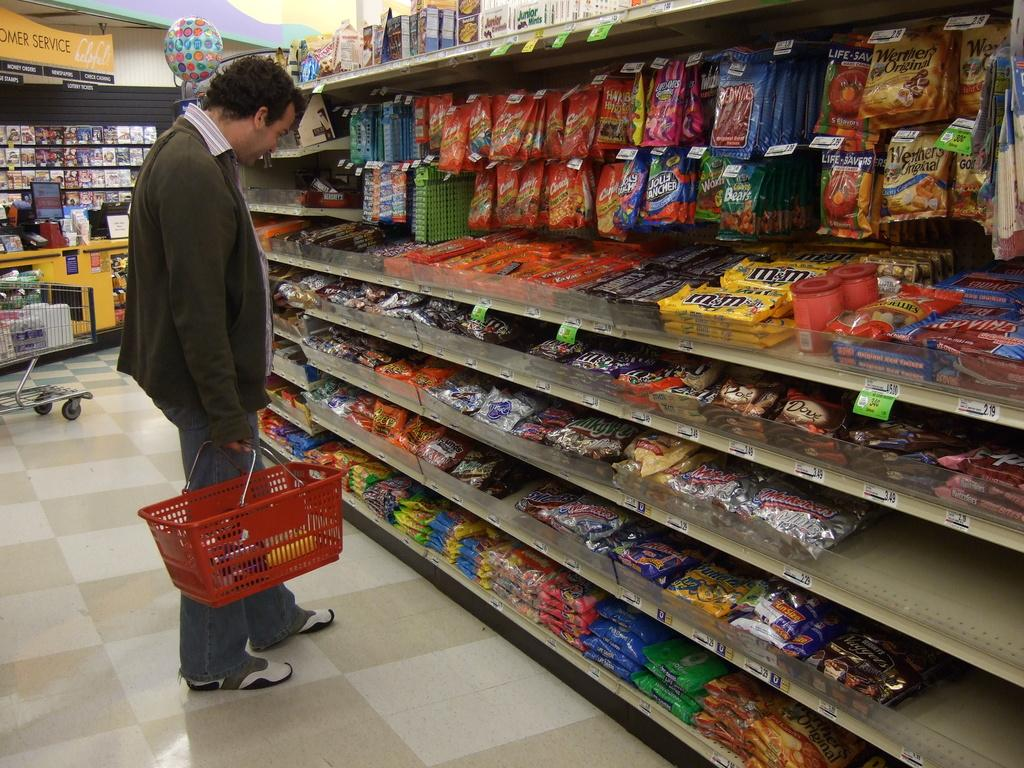<image>
Summarize the visual content of the image. A man is looking at an aisle of candy that has M&M's in it. 